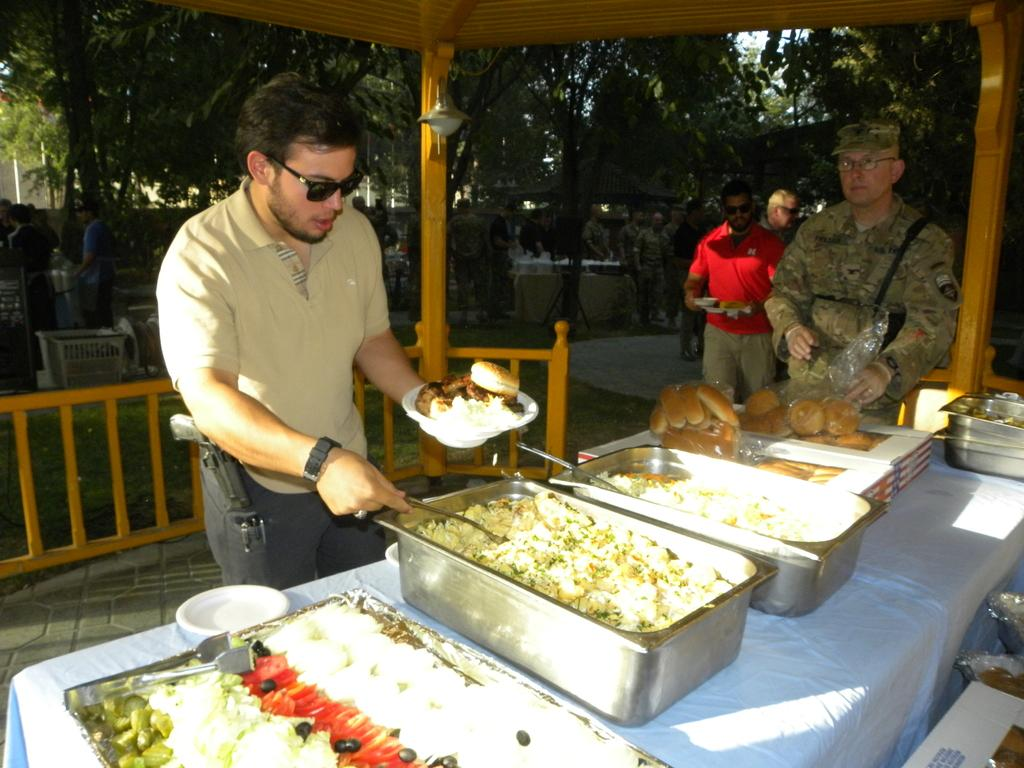What is happening in the image? There are people standing in the image. What can be seen on the table in the image? There are food items on the table in the image. How are the food items arranged or contained? The food items are in vessels. What can be seen in the distance in the image? There are trees visible in the background of the image. What type of advertisement can be seen on the pocket of the person in the image? There is no advertisement visible on the pocket of any person in the image. 